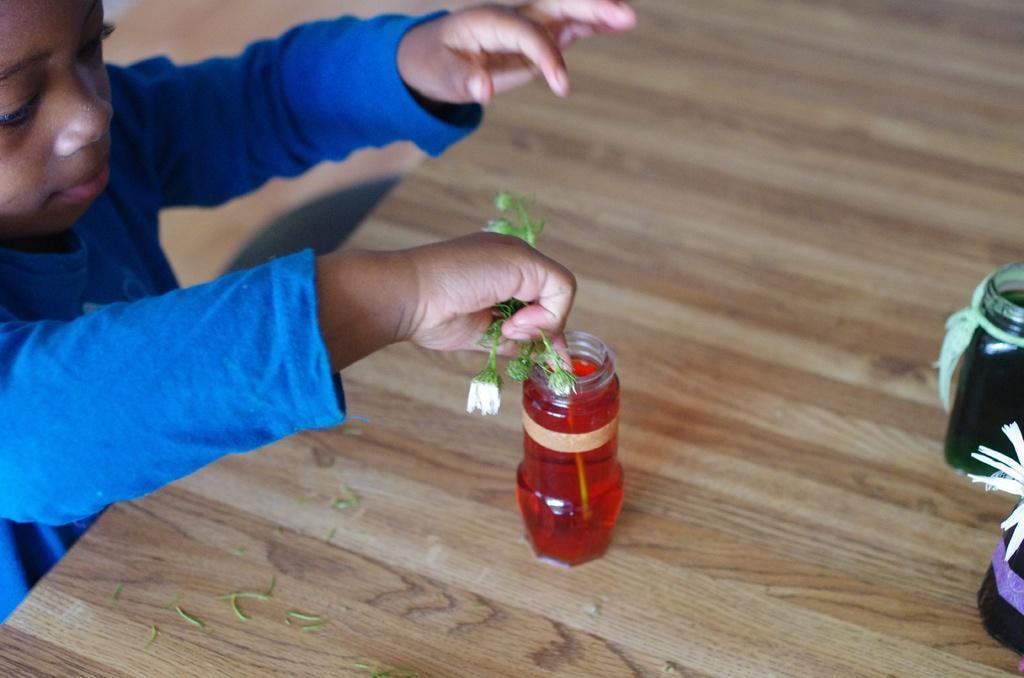How would you summarize this image in a sentence or two? A child wearing a blue dress holding a plant and putting it in a bottle containing red water. There are other two bottles on the table. 